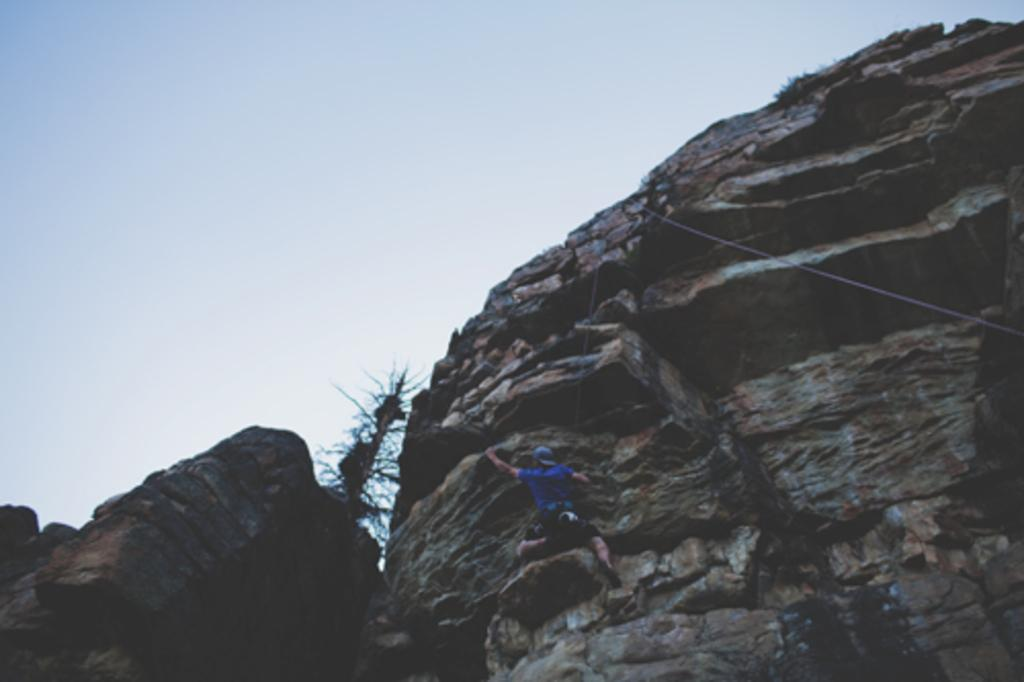Who is the main subject in the image? There is a man in the image. What is the man doing in the image? The man is climbing a rock. Is there any equipment being used by the man in the image? Yes, there is a rope visible in the image. What flavor of hydrant can be seen in the image? There is no hydrant present in the image, so it is not possible to determine the flavor. 